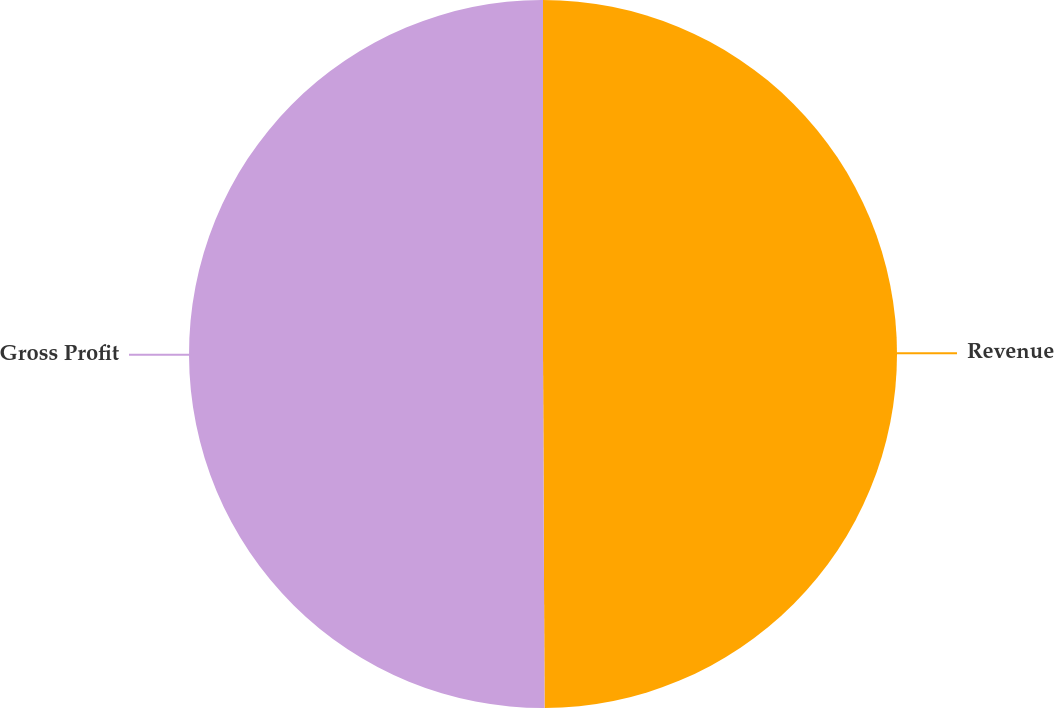Convert chart to OTSL. <chart><loc_0><loc_0><loc_500><loc_500><pie_chart><fcel>Revenue<fcel>Gross Profit<nl><fcel>49.93%<fcel>50.07%<nl></chart> 